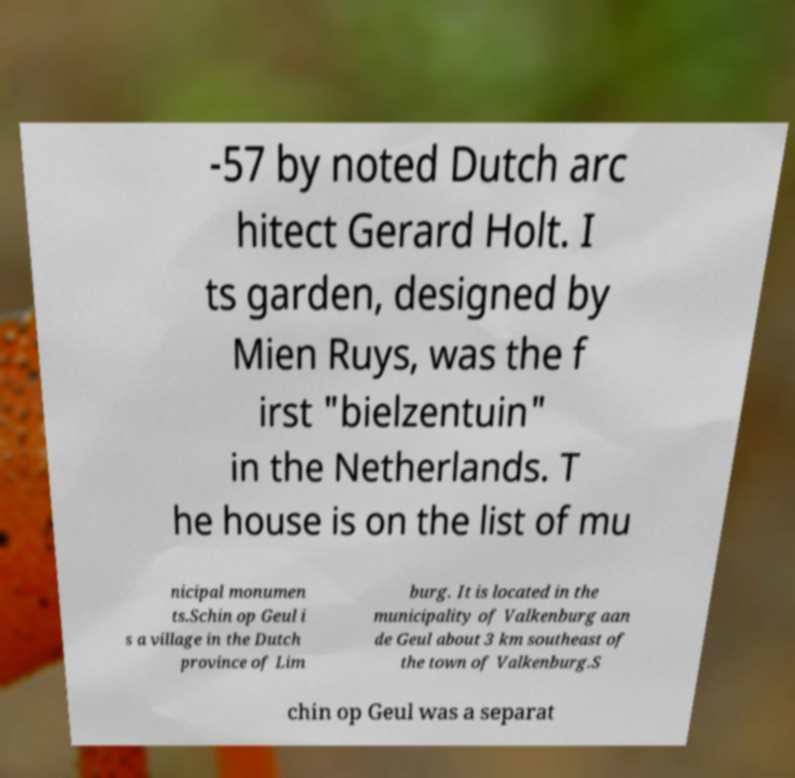Can you read and provide the text displayed in the image?This photo seems to have some interesting text. Can you extract and type it out for me? -57 by noted Dutch arc hitect Gerard Holt. I ts garden, designed by Mien Ruys, was the f irst "bielzentuin" in the Netherlands. T he house is on the list of mu nicipal monumen ts.Schin op Geul i s a village in the Dutch province of Lim burg. It is located in the municipality of Valkenburg aan de Geul about 3 km southeast of the town of Valkenburg.S chin op Geul was a separat 